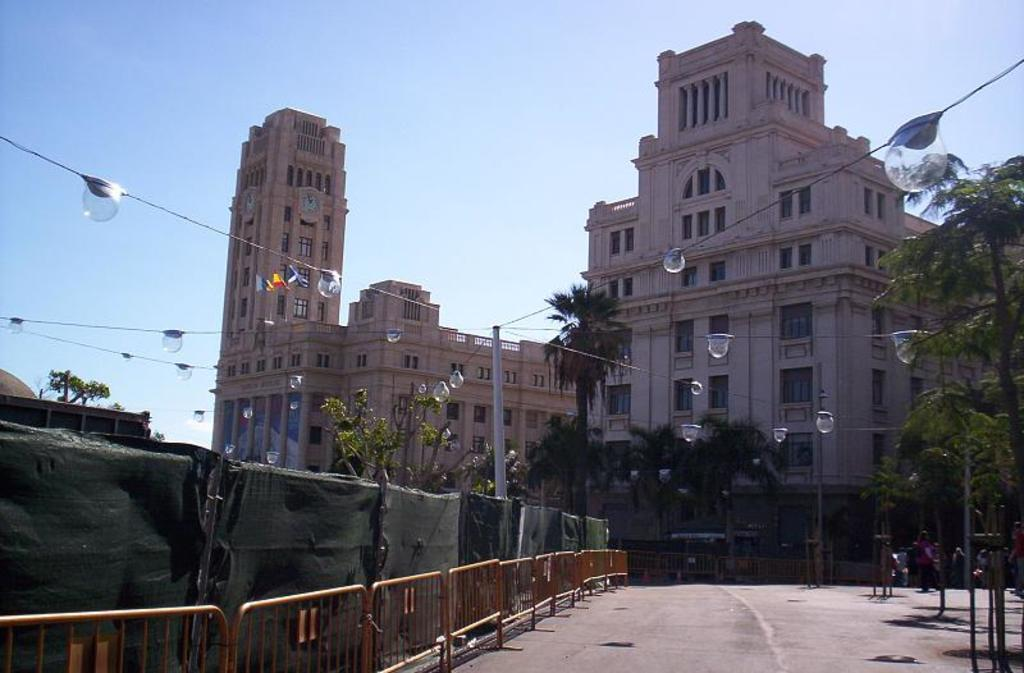What can be seen in the image that might be used to control traffic or access? There are barricades in the image. What is located at the bottom of the image? There is a road at the bottom of the image. What type of natural elements can be seen in the image? Trees are present in the image. What type of man-made structures are visible in the image? Buildings are visible in the image. What is visible in the background of the image? The sky is in the background of the image. What type of trousers is the grandmother wearing in the image? There is no grandmother or trousers present in the image. How does the pollution affect the buildings in the image? There is no mention of pollution in the image, so it cannot be determined how it affects the buildings. 